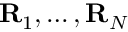<formula> <loc_0><loc_0><loc_500><loc_500>{ R } _ { 1 } , \dots , { R } _ { N }</formula> 